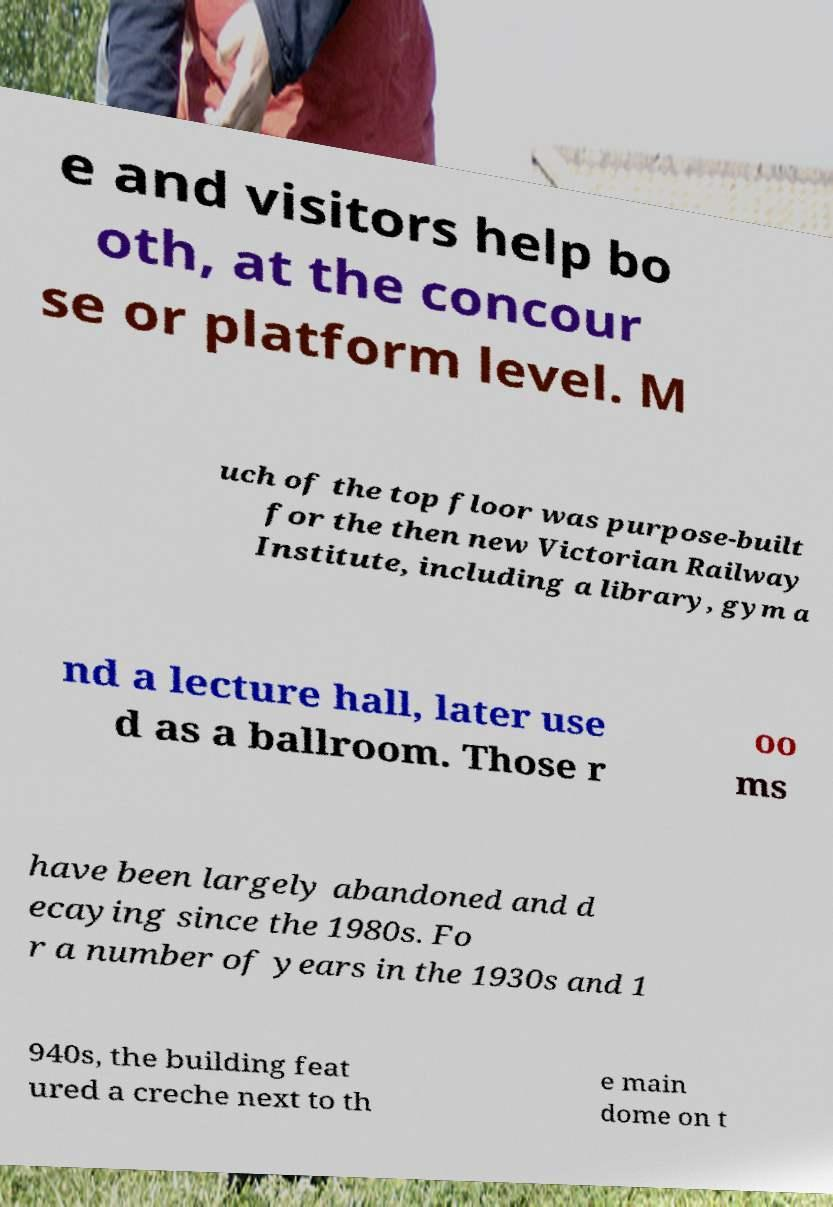Please read and relay the text visible in this image. What does it say? e and visitors help bo oth, at the concour se or platform level. M uch of the top floor was purpose-built for the then new Victorian Railway Institute, including a library, gym a nd a lecture hall, later use d as a ballroom. Those r oo ms have been largely abandoned and d ecaying since the 1980s. Fo r a number of years in the 1930s and 1 940s, the building feat ured a creche next to th e main dome on t 